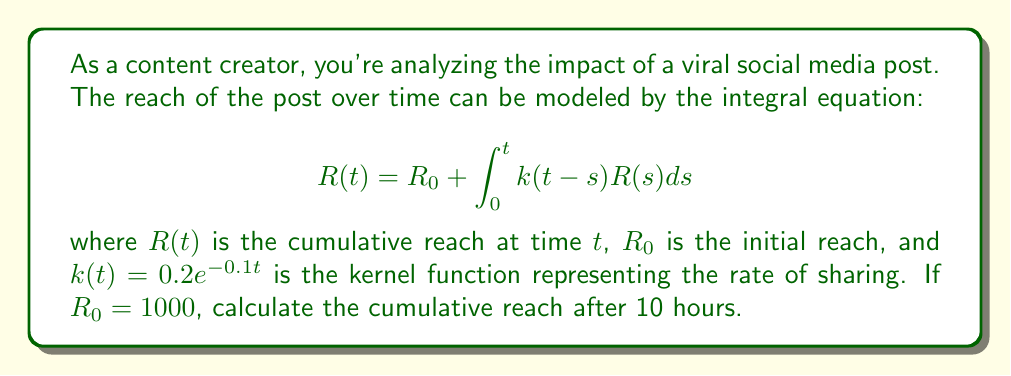What is the answer to this math problem? To solve this integral equation, we'll use the Laplace transform method:

1) Take the Laplace transform of both sides:
   $$\mathcal{L}\{R(t)\} = \mathcal{L}\{R_0\} + \mathcal{L}\{\int_0^t k(t-s)R(s)ds\}$$

2) Using the properties of Laplace transform:
   $$\hat{R}(p) = \frac{R_0}{p} + \hat{k}(p)\hat{R}(p)$$

3) The Laplace transform of $k(t) = 0.2e^{-0.1t}$ is:
   $$\hat{k}(p) = \frac{0.2}{p+0.1}$$

4) Substituting and solving for $\hat{R}(p)$:
   $$\hat{R}(p) = \frac{R_0}{p} + \frac{0.2}{p+0.1}\hat{R}(p)$$
   $$\hat{R}(p)(1 - \frac{0.2}{p+0.1}) = \frac{R_0}{p}$$
   $$\hat{R}(p) = \frac{R_0}{p} \cdot \frac{p+0.1}{p+0.1-0.2} = \frac{1000(p+0.1)}{p(p-0.1)}$$

5) Partial fraction decomposition:
   $$\hat{R}(p) = \frac{1000}{p} + \frac{100}{p-0.1}$$

6) Inverse Laplace transform:
   $$R(t) = 1000 + 100e^{0.1t}$$

7) Evaluate at $t=10$:
   $$R(10) = 1000 + 100e^{0.1(10)} = 1000 + 100e^1 \approx 2718.28$$
Answer: 2718.28 